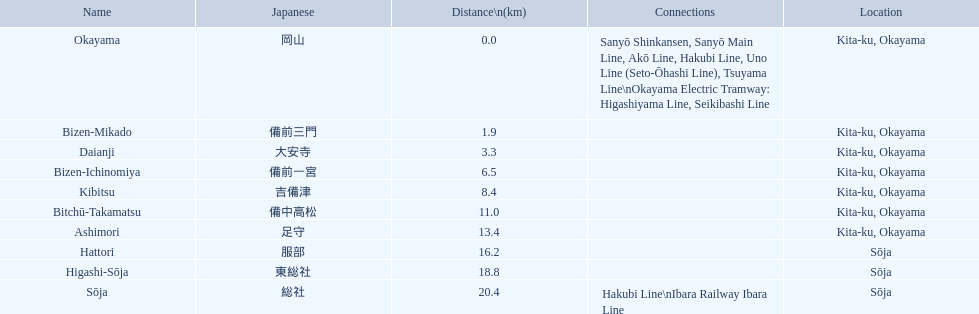What constitutes the kibi line members? Okayama, Bizen-Mikado, Daianji, Bizen-Ichinomiya, Kibitsu, Bitchū-Takamatsu, Ashimori, Hattori, Higashi-Sōja, Sōja. Among them, which ones are over 1 km away? Bizen-Mikado, Daianji, Bizen-Ichinomiya, Kibitsu, Bitchū-Takamatsu, Ashimori, Hattori, Higashi-Sōja, Sōja. Which ones are under 2 km away? Okayama, Bizen-Mikado. And which ones fall in the range of 1 km to 2 km? Bizen-Mikado. 